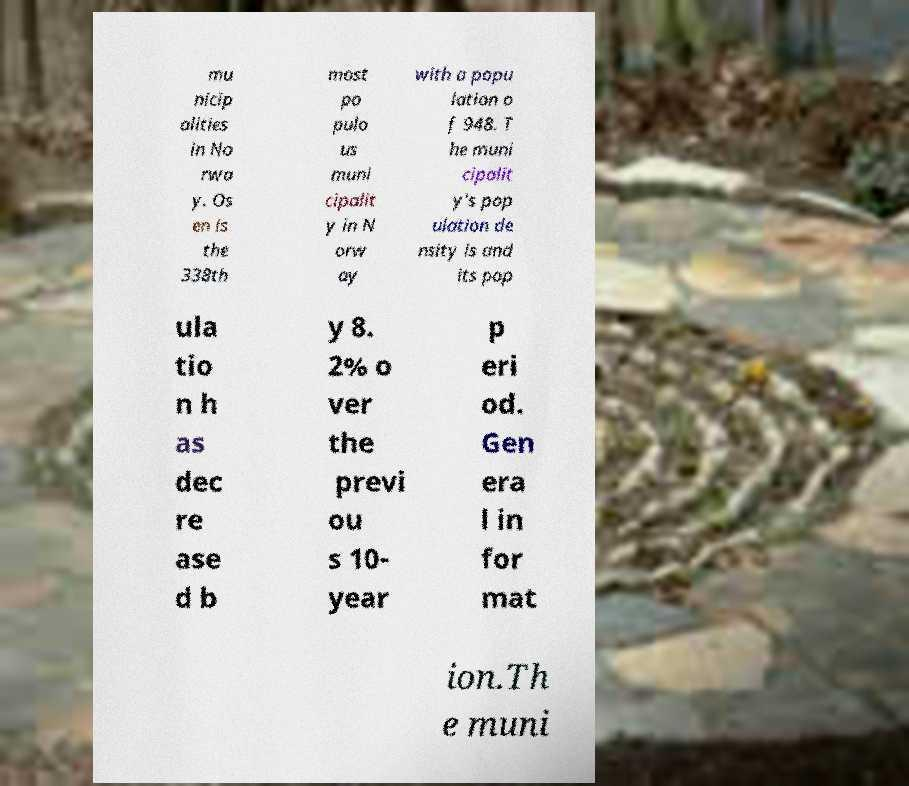For documentation purposes, I need the text within this image transcribed. Could you provide that? mu nicip alities in No rwa y. Os en is the 338th most po pulo us muni cipalit y in N orw ay with a popu lation o f 948. T he muni cipalit y's pop ulation de nsity is and its pop ula tio n h as dec re ase d b y 8. 2% o ver the previ ou s 10- year p eri od. Gen era l in for mat ion.Th e muni 